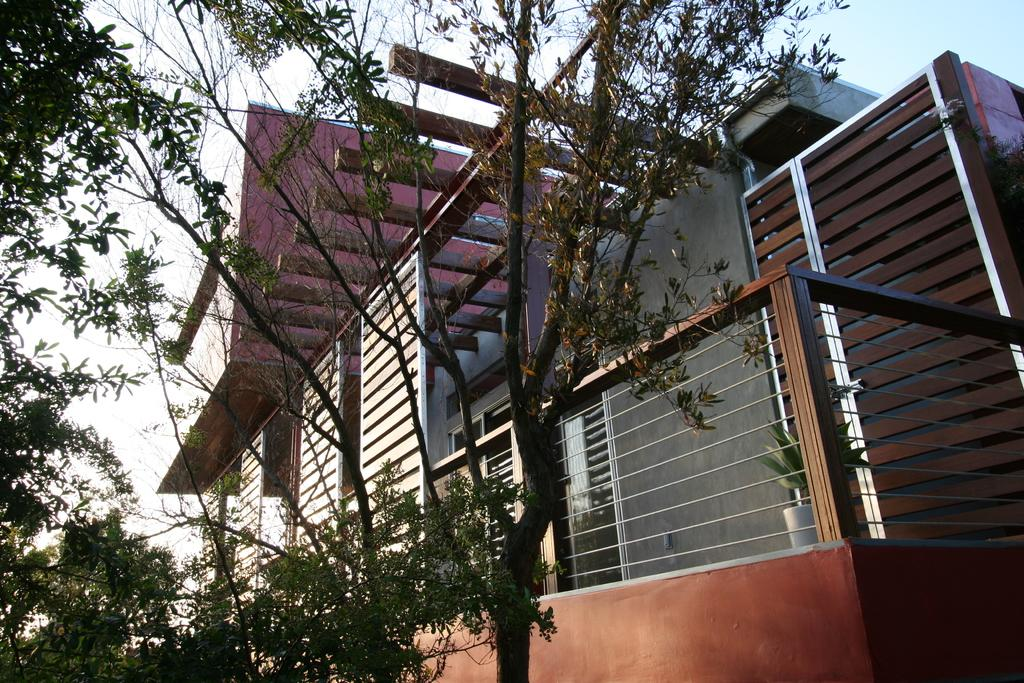What type of structure is visible in the image? There is a building in the image. Are there any plants inside the building? Yes, there is a houseplant in the building. What can be seen on the left side of the image? There are trees on the left side of the image. What type of legal system is being discussed in the image? There is no discussion of a legal system in the image; it features a building, a houseplant, and trees. Can you see a stick being used by someone in the image? There is no stick visible in the image. 